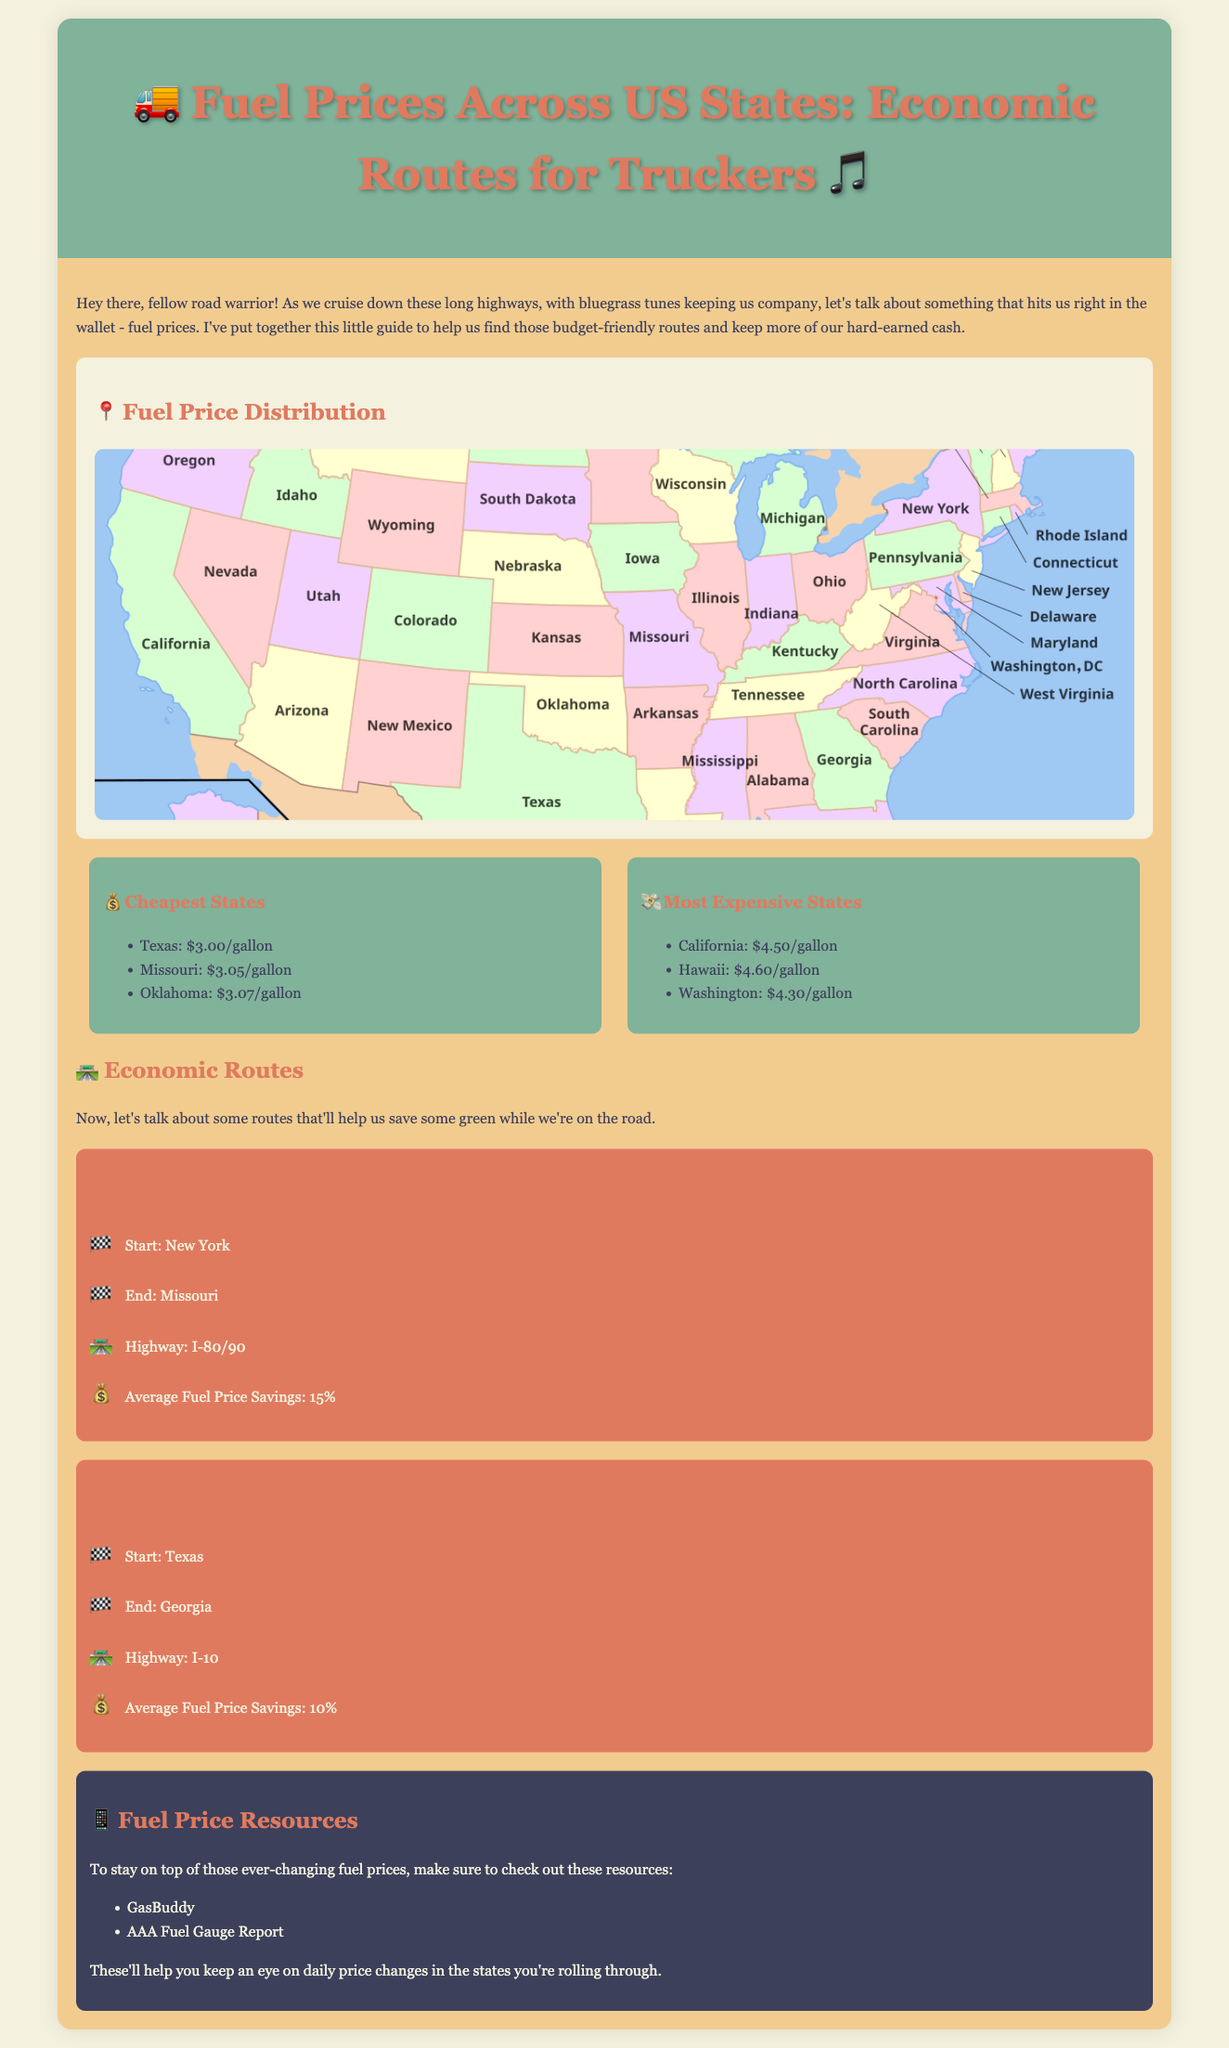What are the cheapest states for fuel prices? The document lists the states with the lowest fuel prices.
Answer: Texas, Missouri, Oklahoma What is the fuel price in California? California is noted as one of the most expensive states for fuel prices.
Answer: $4.50/gallon What is the average fuel price savings on Route 1? The document states the average fuel price savings for this route.
Answer: 15% Which highway is suggested for the Southern States route? The specific highway for this route is mentioned in the document.
Answer: I-10 What resource is recommended for tracking fuel prices? The document lists resources to help monitor fuel prices.
Answer: GasBuddy Which state has the highest fuel price listed? The document highlights California, Hawaii, and Washington being expensive, but one is the highest.
Answer: Hawaii 